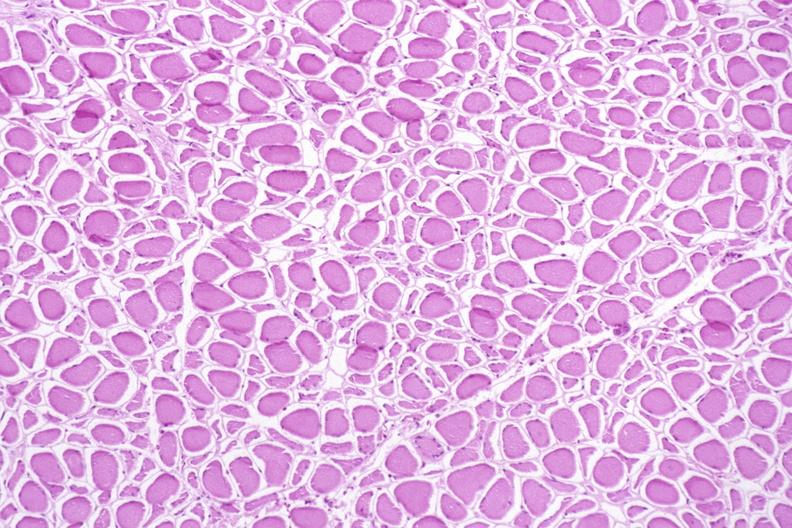what does this image show?
Answer the question using a single word or phrase. Skeletal muscle 